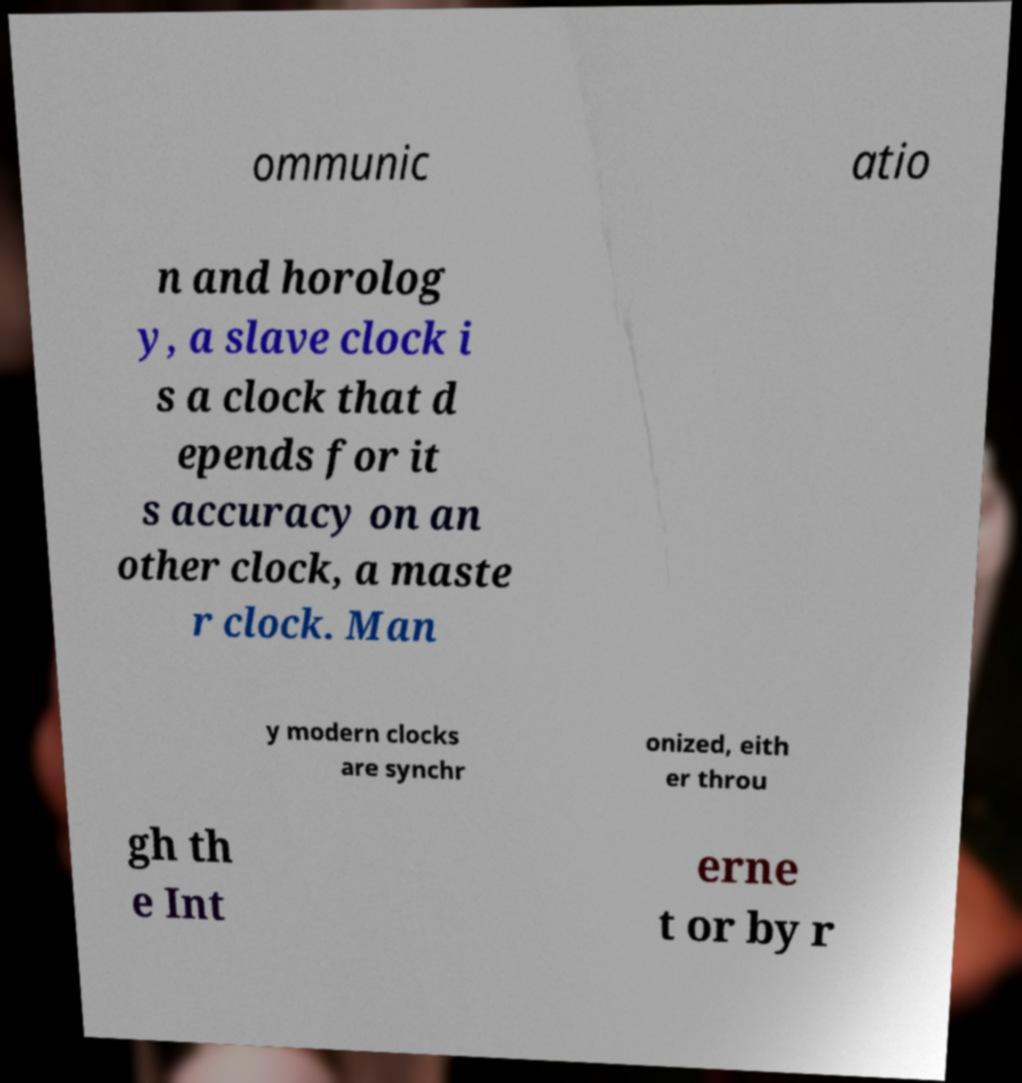Could you extract and type out the text from this image? ommunic atio n and horolog y, a slave clock i s a clock that d epends for it s accuracy on an other clock, a maste r clock. Man y modern clocks are synchr onized, eith er throu gh th e Int erne t or by r 